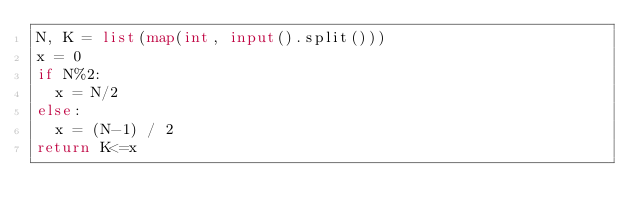<code> <loc_0><loc_0><loc_500><loc_500><_Python_>N, K = list(map(int, input().split()))
x = 0
if N%2:
  x = N/2
else:
  x = (N-1) / 2
return K<=x</code> 